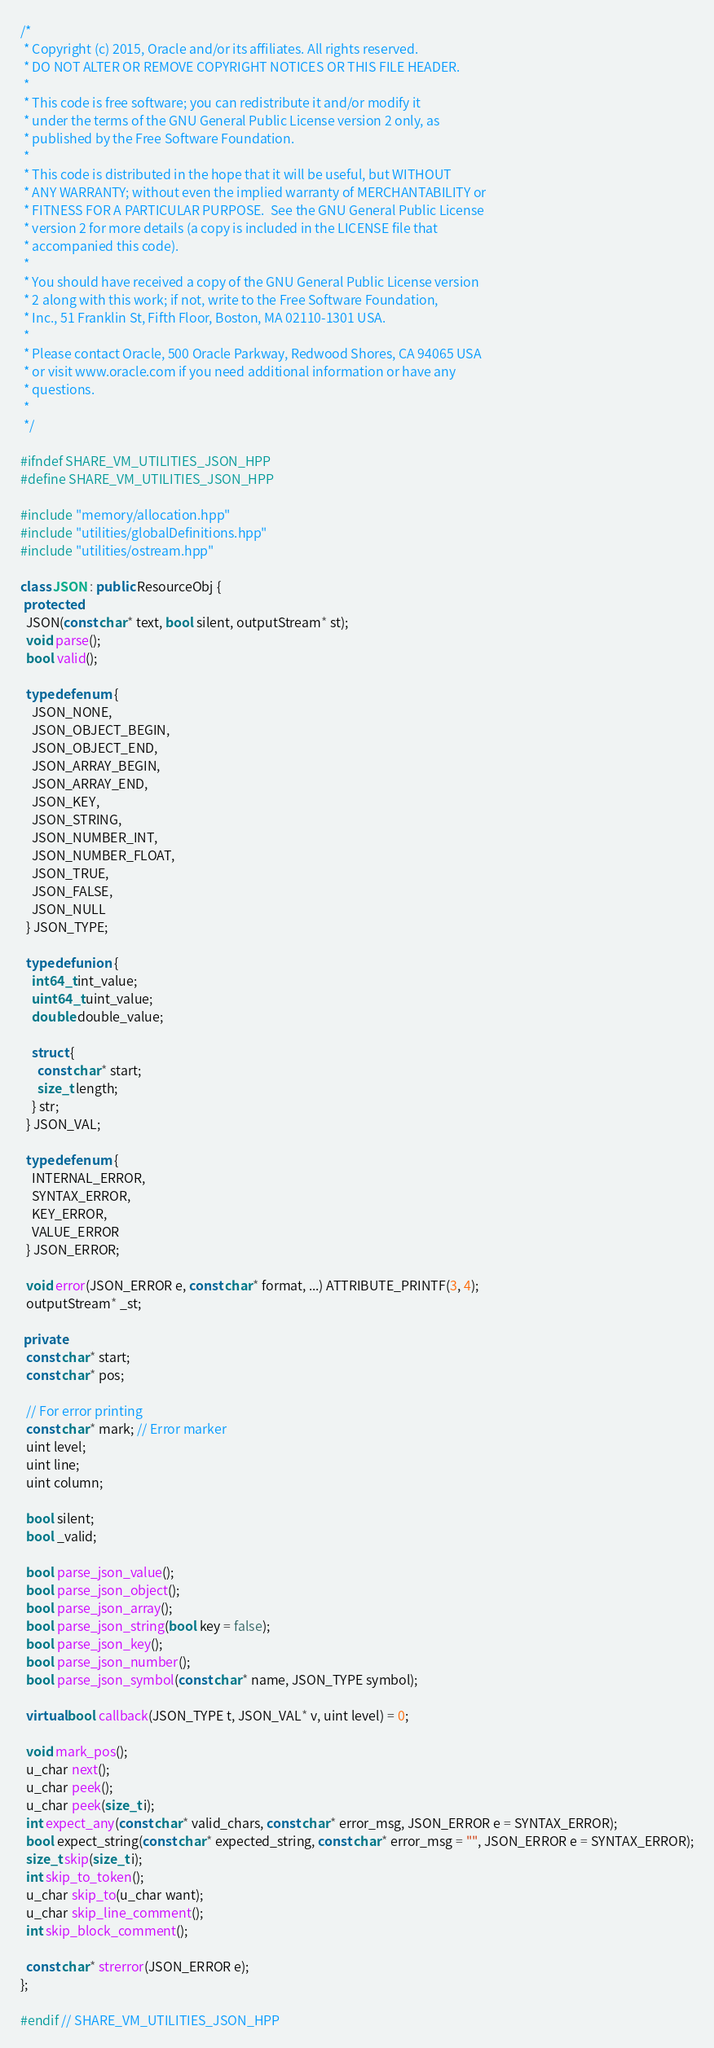<code> <loc_0><loc_0><loc_500><loc_500><_C++_>/*
 * Copyright (c) 2015, Oracle and/or its affiliates. All rights reserved.
 * DO NOT ALTER OR REMOVE COPYRIGHT NOTICES OR THIS FILE HEADER.
 *
 * This code is free software; you can redistribute it and/or modify it
 * under the terms of the GNU General Public License version 2 only, as
 * published by the Free Software Foundation.
 *
 * This code is distributed in the hope that it will be useful, but WITHOUT
 * ANY WARRANTY; without even the implied warranty of MERCHANTABILITY or
 * FITNESS FOR A PARTICULAR PURPOSE.  See the GNU General Public License
 * version 2 for more details (a copy is included in the LICENSE file that
 * accompanied this code).
 *
 * You should have received a copy of the GNU General Public License version
 * 2 along with this work; if not, write to the Free Software Foundation,
 * Inc., 51 Franklin St, Fifth Floor, Boston, MA 02110-1301 USA.
 *
 * Please contact Oracle, 500 Oracle Parkway, Redwood Shores, CA 94065 USA
 * or visit www.oracle.com if you need additional information or have any
 * questions.
 *
 */

#ifndef SHARE_VM_UTILITIES_JSON_HPP
#define SHARE_VM_UTILITIES_JSON_HPP

#include "memory/allocation.hpp"
#include "utilities/globalDefinitions.hpp"
#include "utilities/ostream.hpp"

class JSON : public ResourceObj {
 protected:
  JSON(const char* text, bool silent, outputStream* st);
  void parse();
  bool valid();

  typedef enum {
    JSON_NONE,
    JSON_OBJECT_BEGIN,
    JSON_OBJECT_END,
    JSON_ARRAY_BEGIN,
    JSON_ARRAY_END,
    JSON_KEY,
    JSON_STRING,
    JSON_NUMBER_INT,
    JSON_NUMBER_FLOAT,
    JSON_TRUE,
    JSON_FALSE,
    JSON_NULL
  } JSON_TYPE;

  typedef union {
    int64_t int_value;
    uint64_t uint_value;
    double double_value;

    struct {
      const char* start;
      size_t length;
    } str;
  } JSON_VAL;

  typedef enum {
    INTERNAL_ERROR,
    SYNTAX_ERROR,
    KEY_ERROR,
    VALUE_ERROR
  } JSON_ERROR;

  void error(JSON_ERROR e, const char* format, ...) ATTRIBUTE_PRINTF(3, 4);
  outputStream* _st;

 private:
  const char* start;
  const char* pos;

  // For error printing
  const char* mark; // Error marker
  uint level;
  uint line;
  uint column;

  bool silent;
  bool _valid;

  bool parse_json_value();
  bool parse_json_object();
  bool parse_json_array();
  bool parse_json_string(bool key = false);
  bool parse_json_key();
  bool parse_json_number();
  bool parse_json_symbol(const char* name, JSON_TYPE symbol);

  virtual bool callback(JSON_TYPE t, JSON_VAL* v, uint level) = 0;

  void mark_pos();
  u_char next();
  u_char peek();
  u_char peek(size_t i);
  int expect_any(const char* valid_chars, const char* error_msg, JSON_ERROR e = SYNTAX_ERROR);
  bool expect_string(const char* expected_string, const char* error_msg = "", JSON_ERROR e = SYNTAX_ERROR);
  size_t skip(size_t i);
  int skip_to_token();
  u_char skip_to(u_char want);
  u_char skip_line_comment();
  int skip_block_comment();

  const char* strerror(JSON_ERROR e);
};

#endif // SHARE_VM_UTILITIES_JSON_HPP
</code> 